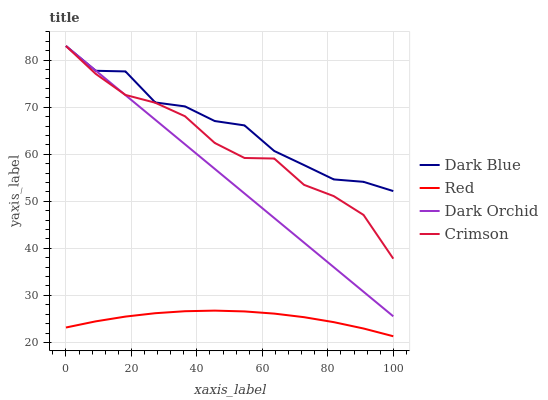Does Red have the minimum area under the curve?
Answer yes or no. Yes. Does Dark Blue have the maximum area under the curve?
Answer yes or no. Yes. Does Dark Orchid have the minimum area under the curve?
Answer yes or no. No. Does Dark Orchid have the maximum area under the curve?
Answer yes or no. No. Is Dark Orchid the smoothest?
Answer yes or no. Yes. Is Dark Blue the roughest?
Answer yes or no. Yes. Is Dark Blue the smoothest?
Answer yes or no. No. Is Dark Orchid the roughest?
Answer yes or no. No. Does Red have the lowest value?
Answer yes or no. Yes. Does Dark Orchid have the lowest value?
Answer yes or no. No. Does Dark Orchid have the highest value?
Answer yes or no. Yes. Does Red have the highest value?
Answer yes or no. No. Is Red less than Dark Blue?
Answer yes or no. Yes. Is Dark Blue greater than Red?
Answer yes or no. Yes. Does Crimson intersect Dark Orchid?
Answer yes or no. Yes. Is Crimson less than Dark Orchid?
Answer yes or no. No. Is Crimson greater than Dark Orchid?
Answer yes or no. No. Does Red intersect Dark Blue?
Answer yes or no. No. 